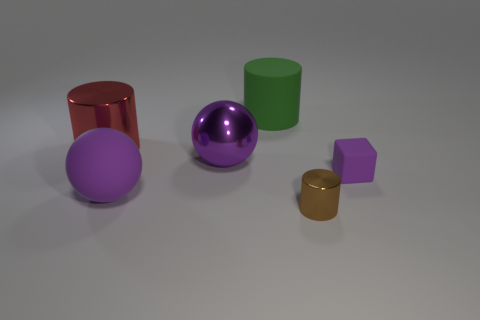What is the material of the small thing that is the same shape as the large green matte thing?
Provide a short and direct response. Metal. How many metal things are either tiny blocks or small cylinders?
Offer a very short reply. 1. Are the object to the right of the brown cylinder and the big object that is right of the big purple metallic thing made of the same material?
Offer a terse response. Yes. Is there a cyan matte cylinder?
Offer a terse response. No. Does the thing behind the large red metal object have the same shape as the big thing that is in front of the purple rubber cube?
Make the answer very short. No. Is there a large purple object that has the same material as the cube?
Ensure brevity in your answer.  Yes. Is the material of the large purple thing that is behind the tiny rubber cube the same as the small purple block?
Give a very brief answer. No. Is the number of shiny cylinders that are right of the large rubber cylinder greater than the number of big shiny things right of the brown object?
Your answer should be very brief. Yes. The cylinder that is the same size as the purple rubber cube is what color?
Offer a very short reply. Brown. Is there a large metal sphere of the same color as the block?
Make the answer very short. Yes. 